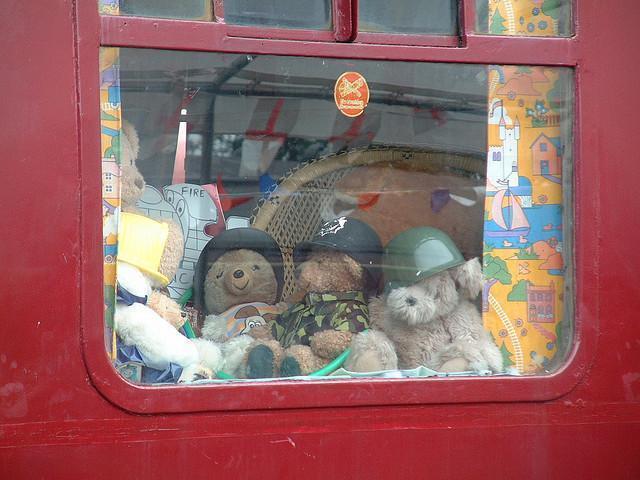What are the toys in the window called?
Answer the question by selecting the correct answer among the 4 following choices.
Options: Footballs, barbie dolls, horseshoes, teddy bears. Teddy bears. 